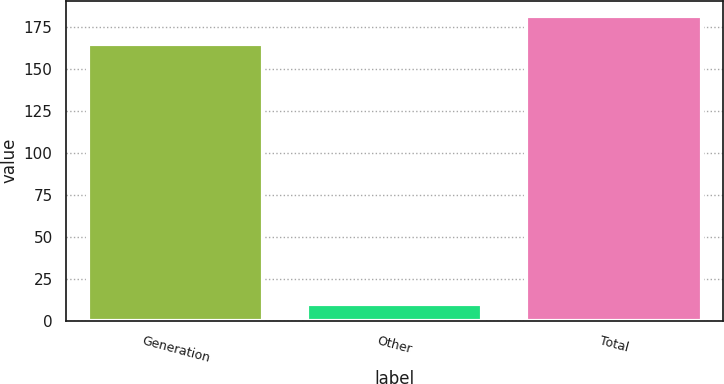<chart> <loc_0><loc_0><loc_500><loc_500><bar_chart><fcel>Generation<fcel>Other<fcel>Total<nl><fcel>165<fcel>10<fcel>181.5<nl></chart> 